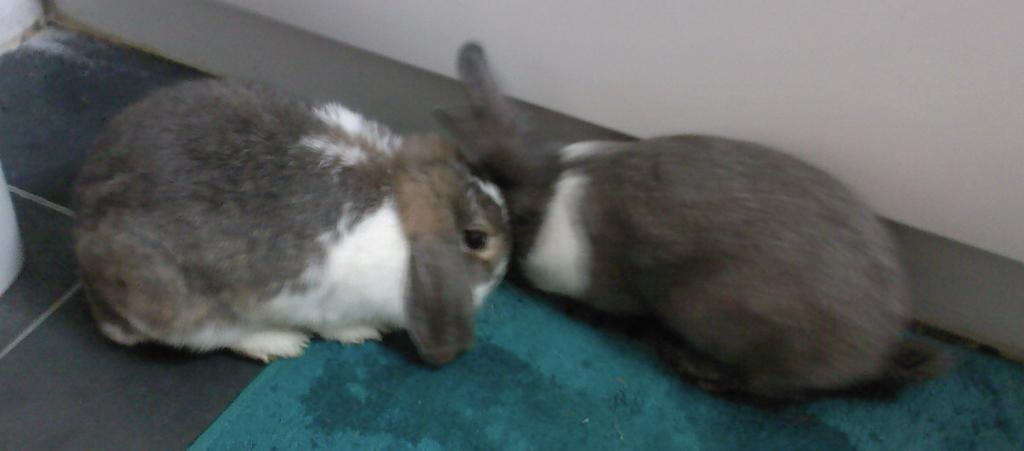How many animals are present in the image? There are two animals in the image. What colors are the animals? The animals are in gray and white color. What is in front of the animals? There is a cloth in green color in front of the animals. What color is the background wall? The background wall is in white color. Are the animals wearing crowns in the image? No, the animals are not wearing crowns in the image. Can you see a sink in the image? No, there is no sink present in the image. 